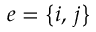Convert formula to latex. <formula><loc_0><loc_0><loc_500><loc_500>e = { \left \{ i , \, j \right \} }</formula> 